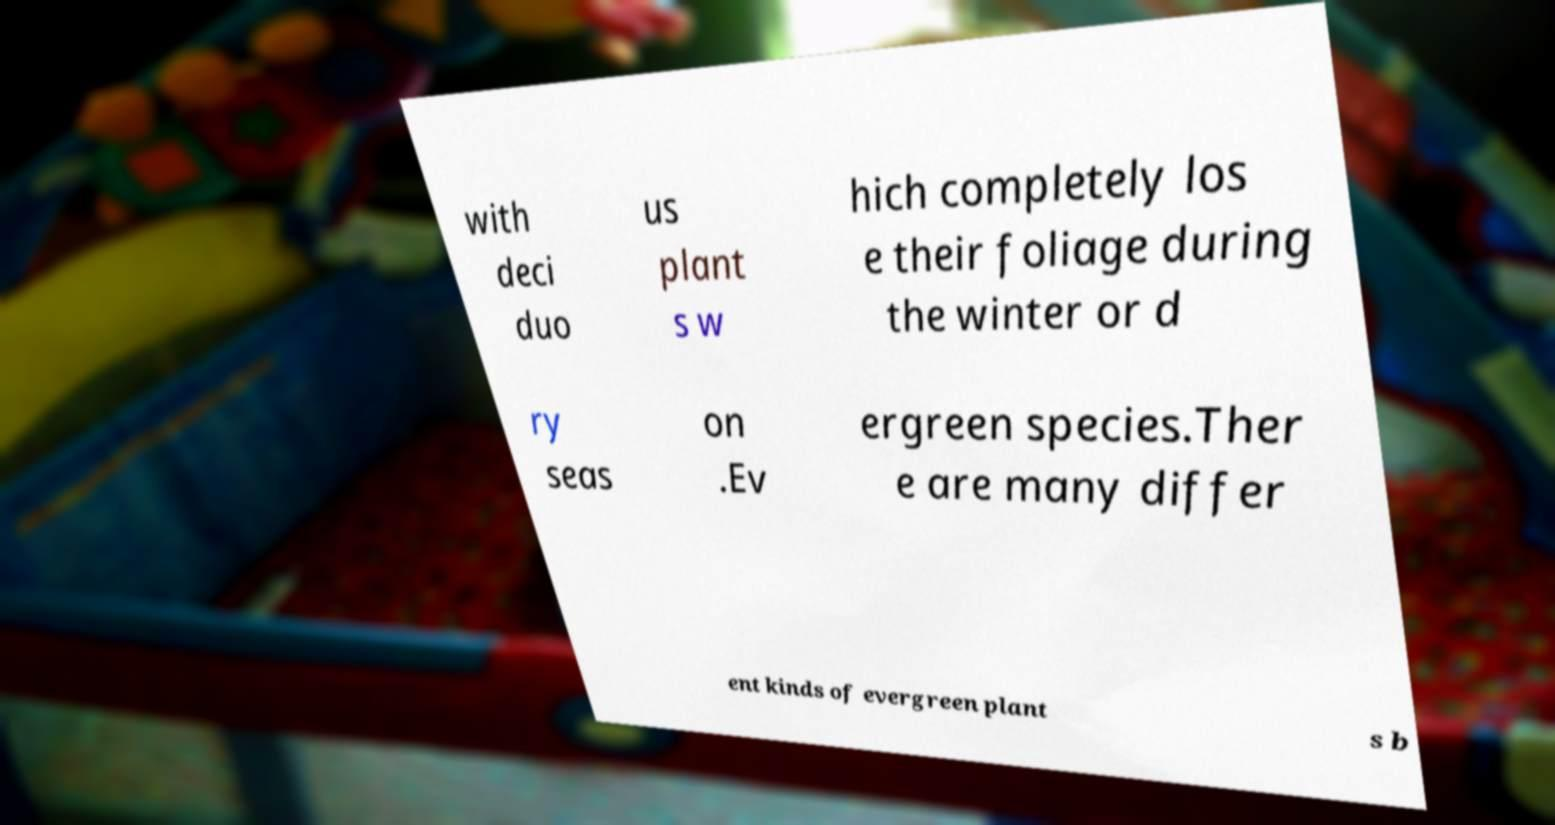I need the written content from this picture converted into text. Can you do that? with deci duo us plant s w hich completely los e their foliage during the winter or d ry seas on .Ev ergreen species.Ther e are many differ ent kinds of evergreen plant s b 